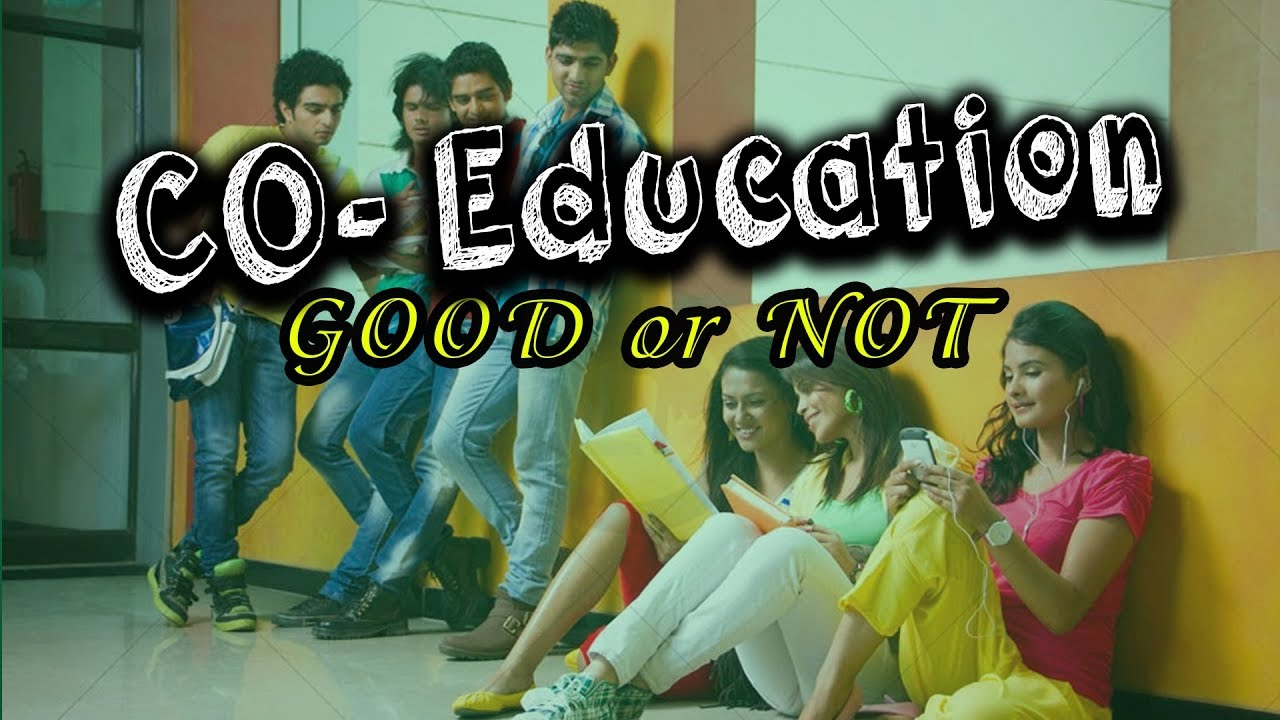Considering the colors and style of clothing, what might this say about the personalities or preferences of the individuals? The vibrant and varied colors worn by the individuals reflect a youthful and perhaps more laid-back approach to fashion. Bright yellows, pinks, and greens are indicative of preferences for clothing that stands out, hinting at personalities that are expressive and confident. Casual styles, like jeans and sneakers, suggest comfort is also a priority for these individuals. How does the overall composition of the image, with the individuals positioned along the corridor, contribute to the storytelling of this scene? The linear arrangement of the individuals along the hallway allows the viewer's eye to travel through the scene, taking in each person's activity one by one. This layout conveys a sense of individual spaces within a shared environment, symbolizing how personal goals can coexist within group dynamics. It also evokes a sense of movement and continuity, which is common in educational settings as students engage in various activities throughout the day. 